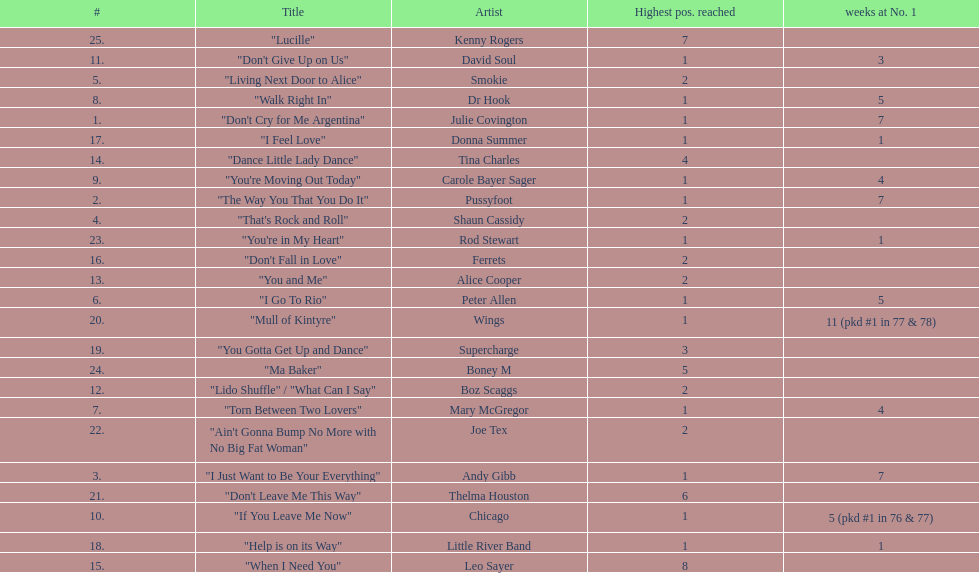Who had the most weeks at number one, according to the table? Wings. 